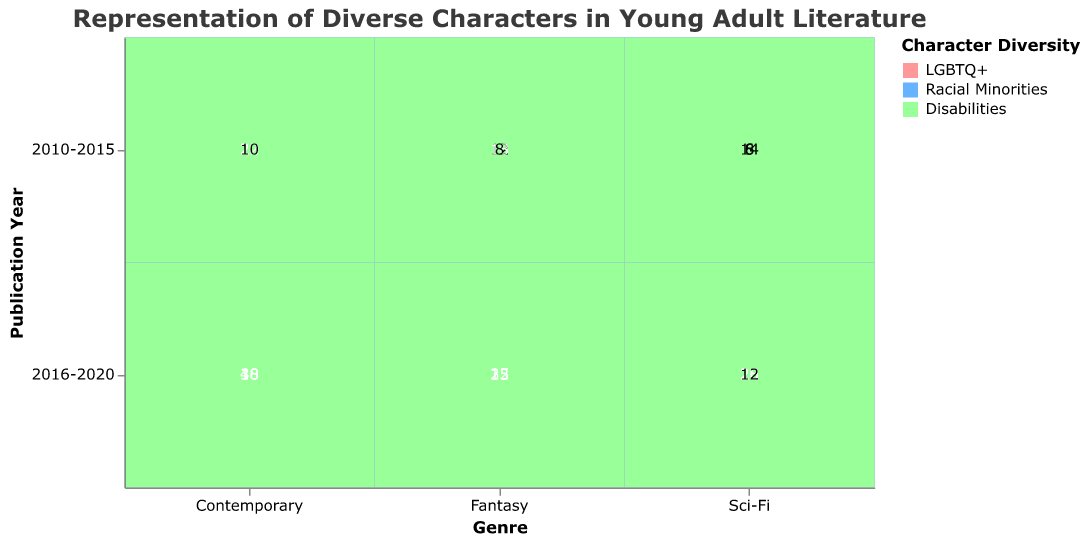What's the title of the figure? The title is located at the top of the figure, it reads: "Representation of Diverse Characters in Young Adult Literature".
Answer: Representation of Diverse Characters in Young Adult Literature What are the two publication years shown in the plot? The publication years are shown on the y-axis as categories. They are "2010-2015" and "2016-2020".
Answer: 2010-2015 and 2016-2020 How many books of the Fantasy genre feature LGBTQ+ characters between 2010 and 2015? By inspecting the Fantasy genre for the publication years between 2010 and 2015, it shows 12 books featuring LGBTQ+ characters.
Answer: 12 Which genre features the highest count of books with racial minorities characters in the 2016-2020 period? By comparing the counts for the 2016-2020 period across all genres, Contemporary has the highest count with 40 books featuring racial minorities characters.
Answer: Contemporary Which diversity category shows the most significant increase in the Sci-Fi genre from 2010-2015 to 2016-2020? We compare the counts for each diversity category in Sci-Fi from 2010-2015 to 2016-2020:
LGBTQ+ increased from 8 to 20 (increase of 12),
Racial Minorities increased from 14 to 28 (increase of 14),
Disabilities increased from 6 to 12 (increase of 6).
The category with the highest increase is Racial Minorities with an increase of 14.
Answer: Racial Minorities What is the combined count of books featuring characters with disabilities in all genres for the 2016-2020 period? Sum the counts for the 'Disabilities' category across all genres for 2016-2020:
Fantasy: 15, Contemporary: 18, Sci-Fi: 12. 
15 + 18 + 12 = 45.
Answer: 45 In which genre and publication period is the representation of LGBTQ+ characters the lowest? By examining the counts for LGBTQ+ characters in all genres and periods, the Sci-Fi genre in 2010-2015 has the lowest count with 8 books.
Answer: Sci-Fi, 2010-2015 How does the representation of racial minorities and disabilities characters in Fantasy compare in the periods of 2010-2015 versus 2016-2020? Compare the counts for each category in Fantasy:
Racial Minorities: 2010-2015 = 18, 2016-2020 = 32 (increase of 14),
Disabilities: 2010-2015 = 8, 2016-2020 = 15 (increase of 7).
Racial Minorities saw a higher increase compared to Disabilities in the Fantasy genre.
Answer: Racial Minorities increased by 14, Disabilities increased by 7 What is the total number of books featuring LGBTQ+ characters across all genres and periods? Sum the counts for the LGBTQ+ category across all genres and periods:
Fantasy (2010-2015: 12, 2016-2020: 25),
Contemporary (2010-2015: 20, 2016-2020: 38),
Sci-Fi (2010-2015: 8, 2016-2020: 20).
12 + 25 + 20 + 38 + 8 + 20 = 123.
Answer: 123 